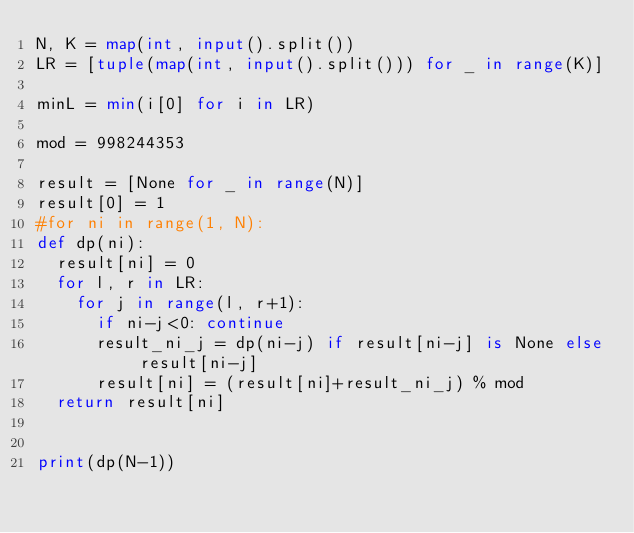<code> <loc_0><loc_0><loc_500><loc_500><_Python_>N, K = map(int, input().split())
LR = [tuple(map(int, input().split())) for _ in range(K)]

minL = min(i[0] for i in LR)

mod = 998244353

result = [None for _ in range(N)]
result[0] = 1
#for ni in range(1, N):
def dp(ni):
  result[ni] = 0
  for l, r in LR:
    for j in range(l, r+1):
      if ni-j<0: continue
      result_ni_j = dp(ni-j) if result[ni-j] is None else result[ni-j]
      result[ni] = (result[ni]+result_ni_j) % mod
  return result[ni]


print(dp(N-1))
</code> 